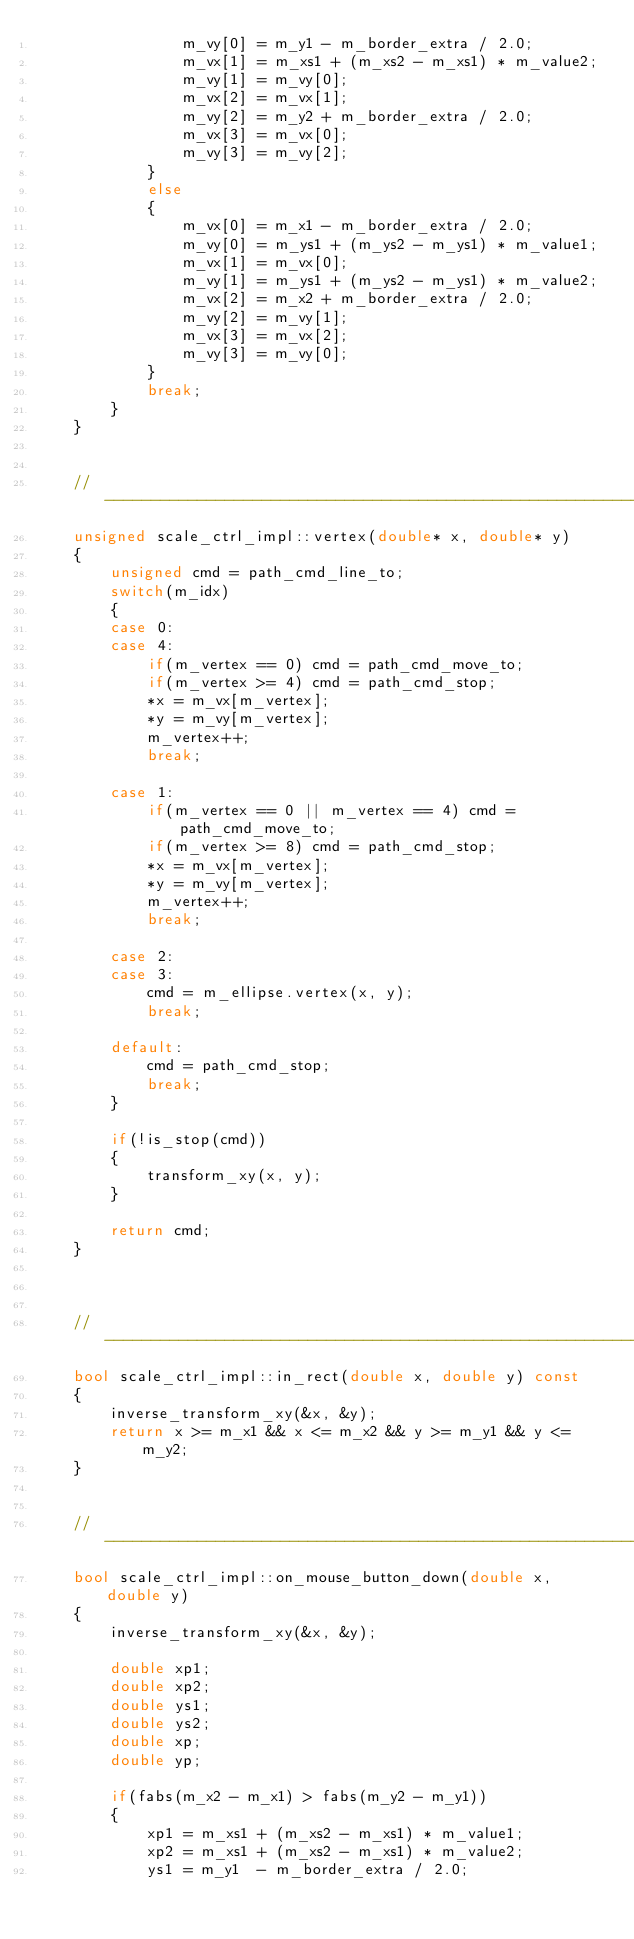<code> <loc_0><loc_0><loc_500><loc_500><_C++_>                m_vy[0] = m_y1 - m_border_extra / 2.0;
                m_vx[1] = m_xs1 + (m_xs2 - m_xs1) * m_value2; 
                m_vy[1] = m_vy[0];
                m_vx[2] = m_vx[1]; 
                m_vy[2] = m_y2 + m_border_extra / 2.0;
                m_vx[3] = m_vx[0]; 
                m_vy[3] = m_vy[2];
            }
            else
            {
                m_vx[0] = m_x1 - m_border_extra / 2.0;
                m_vy[0] = m_ys1 + (m_ys2 - m_ys1) * m_value1;
                m_vx[1] = m_vx[0];
                m_vy[1] = m_ys1 + (m_ys2 - m_ys1) * m_value2; 
                m_vx[2] = m_x2 + m_border_extra / 2.0;
                m_vy[2] = m_vy[1]; 
                m_vx[3] = m_vx[2];
                m_vy[3] = m_vy[0]; 
            }
            break;
        }
    }


    //------------------------------------------------------------------------
    unsigned scale_ctrl_impl::vertex(double* x, double* y)
    {
        unsigned cmd = path_cmd_line_to;
        switch(m_idx)
        {
        case 0:
        case 4:
            if(m_vertex == 0) cmd = path_cmd_move_to;
            if(m_vertex >= 4) cmd = path_cmd_stop;
            *x = m_vx[m_vertex];
            *y = m_vy[m_vertex];
            m_vertex++;
            break;

        case 1:
            if(m_vertex == 0 || m_vertex == 4) cmd = path_cmd_move_to;
            if(m_vertex >= 8) cmd = path_cmd_stop;
            *x = m_vx[m_vertex];
            *y = m_vy[m_vertex];
            m_vertex++;
            break;

        case 2:
        case 3:
            cmd = m_ellipse.vertex(x, y);
            break;

        default:
            cmd = path_cmd_stop;
            break;
        }

        if(!is_stop(cmd))
        {
            transform_xy(x, y);
        }

        return cmd;
    }



    //------------------------------------------------------------------------
    bool scale_ctrl_impl::in_rect(double x, double y) const
    {
        inverse_transform_xy(&x, &y);
        return x >= m_x1 && x <= m_x2 && y >= m_y1 && y <= m_y2;
    }


    //------------------------------------------------------------------------
    bool scale_ctrl_impl::on_mouse_button_down(double x, double y)
    {
        inverse_transform_xy(&x, &y);

        double xp1;
        double xp2;
        double ys1;
        double ys2;
        double xp;
        double yp;

        if(fabs(m_x2 - m_x1) > fabs(m_y2 - m_y1))
        {
            xp1 = m_xs1 + (m_xs2 - m_xs1) * m_value1;
            xp2 = m_xs1 + (m_xs2 - m_xs1) * m_value2;
            ys1 = m_y1  - m_border_extra / 2.0;</code> 